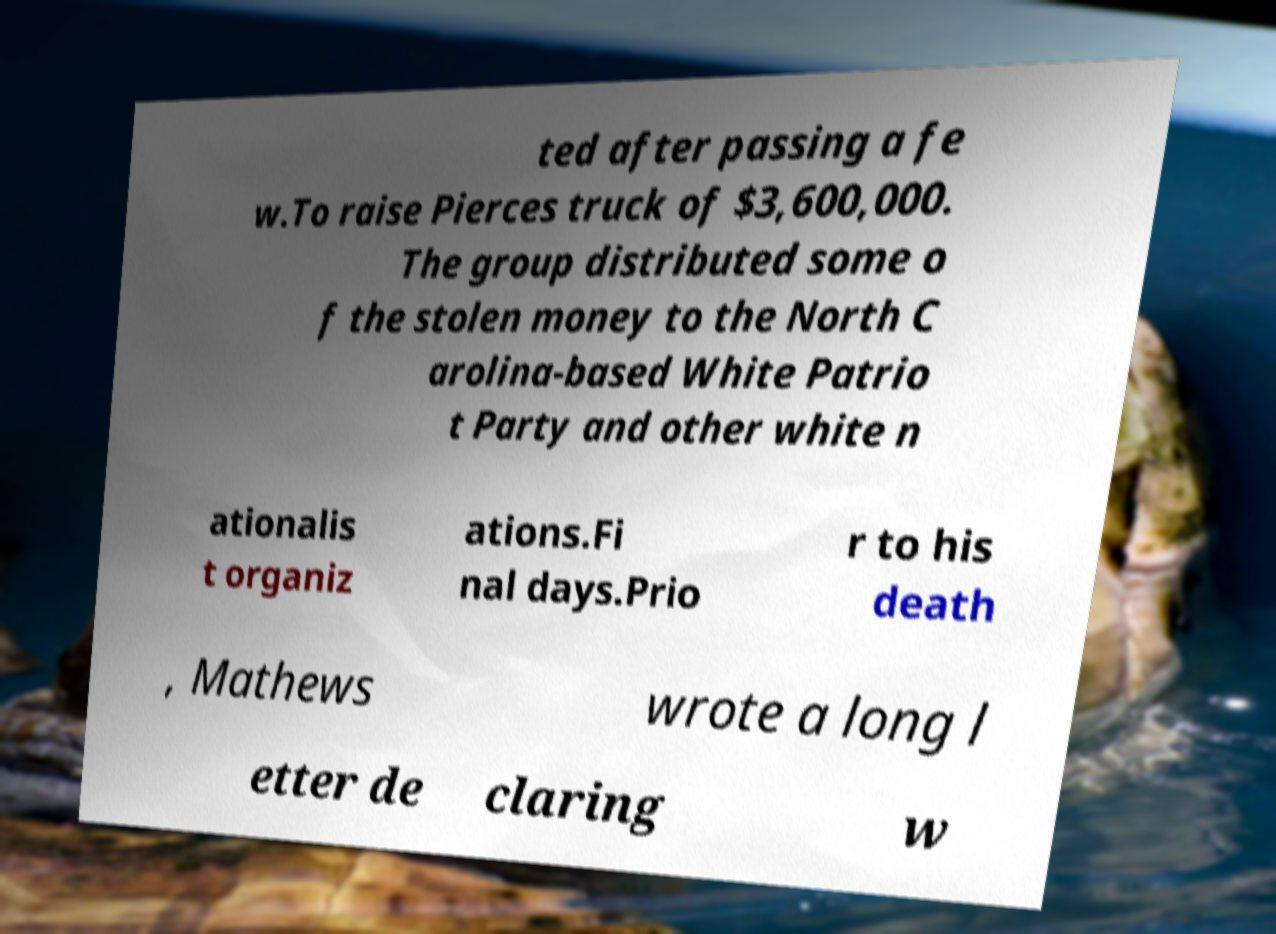Please identify and transcribe the text found in this image. ted after passing a fe w.To raise Pierces truck of $3,600,000. The group distributed some o f the stolen money to the North C arolina-based White Patrio t Party and other white n ationalis t organiz ations.Fi nal days.Prio r to his death , Mathews wrote a long l etter de claring w 